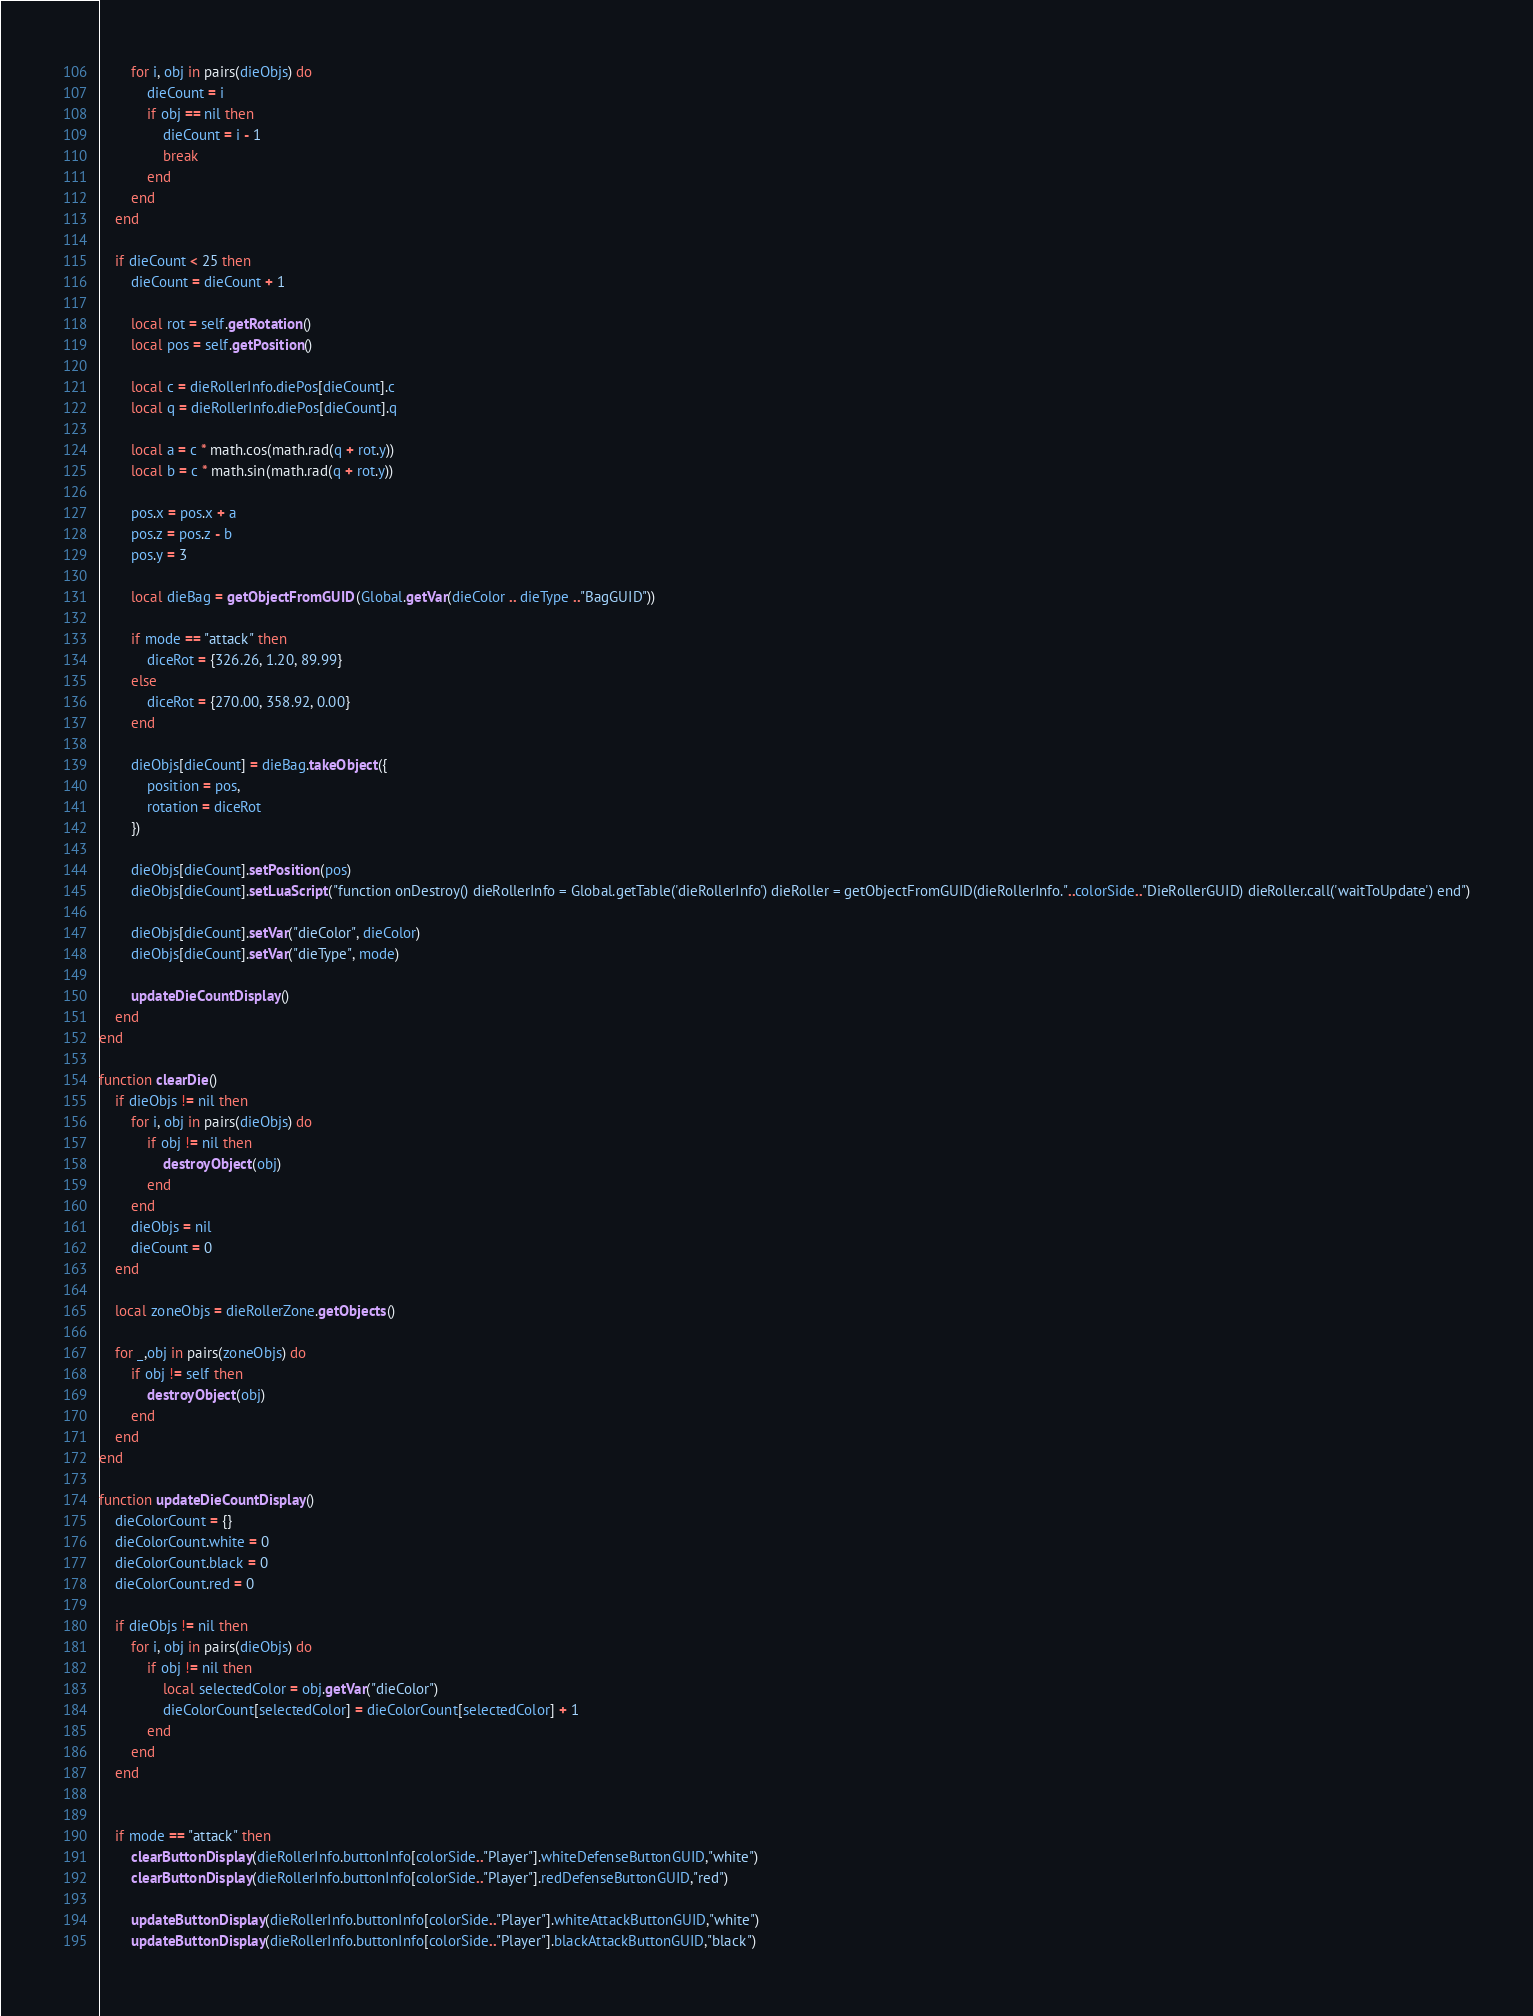<code> <loc_0><loc_0><loc_500><loc_500><_Lua_>        for i, obj in pairs(dieObjs) do
            dieCount = i
            if obj == nil then
                dieCount = i - 1
                break
            end
        end
    end

    if dieCount < 25 then
        dieCount = dieCount + 1

        local rot = self.getRotation()
        local pos = self.getPosition()

        local c = dieRollerInfo.diePos[dieCount].c
        local q = dieRollerInfo.diePos[dieCount].q

        local a = c * math.cos(math.rad(q + rot.y))
        local b = c * math.sin(math.rad(q + rot.y))

        pos.x = pos.x + a
        pos.z = pos.z - b
        pos.y = 3

        local dieBag = getObjectFromGUID(Global.getVar(dieColor .. dieType .."BagGUID"))

        if mode == "attack" then
            diceRot = {326.26, 1.20, 89.99}
        else
            diceRot = {270.00, 358.92, 0.00}
        end

        dieObjs[dieCount] = dieBag.takeObject({
            position = pos,
            rotation = diceRot
        })

        dieObjs[dieCount].setPosition(pos)
        dieObjs[dieCount].setLuaScript("function onDestroy() dieRollerInfo = Global.getTable('dieRollerInfo') dieRoller = getObjectFromGUID(dieRollerInfo."..colorSide.."DieRollerGUID) dieRoller.call('waitToUpdate') end")

        dieObjs[dieCount].setVar("dieColor", dieColor)
        dieObjs[dieCount].setVar("dieType", mode)

        updateDieCountDisplay()
    end
end

function clearDie()
    if dieObjs != nil then
        for i, obj in pairs(dieObjs) do
            if obj != nil then
                destroyObject(obj)
            end
        end
        dieObjs = nil
        dieCount = 0
    end

    local zoneObjs = dieRollerZone.getObjects()

    for _,obj in pairs(zoneObjs) do
        if obj != self then
            destroyObject(obj)
        end
    end
end

function updateDieCountDisplay()
    dieColorCount = {}
    dieColorCount.white = 0
    dieColorCount.black = 0
    dieColorCount.red = 0

    if dieObjs != nil then
        for i, obj in pairs(dieObjs) do
            if obj != nil then
                local selectedColor = obj.getVar("dieColor")
                dieColorCount[selectedColor] = dieColorCount[selectedColor] + 1
            end
        end
    end


    if mode == "attack" then
        clearButtonDisplay(dieRollerInfo.buttonInfo[colorSide.."Player"].whiteDefenseButtonGUID,"white")
        clearButtonDisplay(dieRollerInfo.buttonInfo[colorSide.."Player"].redDefenseButtonGUID,"red")

        updateButtonDisplay(dieRollerInfo.buttonInfo[colorSide.."Player"].whiteAttackButtonGUID,"white")
        updateButtonDisplay(dieRollerInfo.buttonInfo[colorSide.."Player"].blackAttackButtonGUID,"black")</code> 